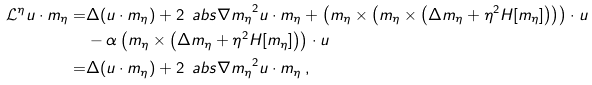Convert formula to latex. <formula><loc_0><loc_0><loc_500><loc_500>\mathcal { L } ^ { \eta } u \cdot m _ { \eta } = & \Delta ( u \cdot m _ { \eta } ) + 2 \, \ a b s { \nabla m _ { \eta } } ^ { 2 } u \cdot m _ { \eta } + \left ( m _ { \eta } \times \left ( m _ { \eta } \times \left ( \Delta m _ { \eta } + \eta ^ { 2 } H [ m _ { \eta } ] \right ) \right ) \right ) \cdot u \\ & - \alpha \left ( m _ { \eta } \times \left ( \Delta m _ { \eta } + \eta ^ { 2 } H [ m _ { \eta } ] \right ) \right ) \cdot u \\ = & \Delta ( u \cdot m _ { \eta } ) + 2 \, \ a b s { \nabla m _ { \eta } } ^ { 2 } u \cdot m _ { \eta } \, ,</formula> 